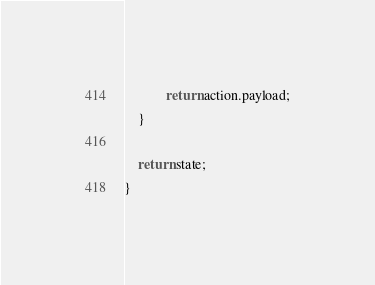Convert code to text. <code><loc_0><loc_0><loc_500><loc_500><_JavaScript_>            return action.payload;
    }

    return state;
}</code> 